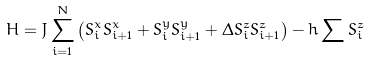<formula> <loc_0><loc_0><loc_500><loc_500>H = J \sum _ { i = 1 } ^ { N } \left ( S ^ { x } _ { i } S ^ { x } _ { i + 1 } + S ^ { y } _ { i } S ^ { y } _ { i + 1 } + \Delta S ^ { z } _ { i } S ^ { z } _ { i + 1 } \right ) - h \sum S ^ { z } _ { i }</formula> 